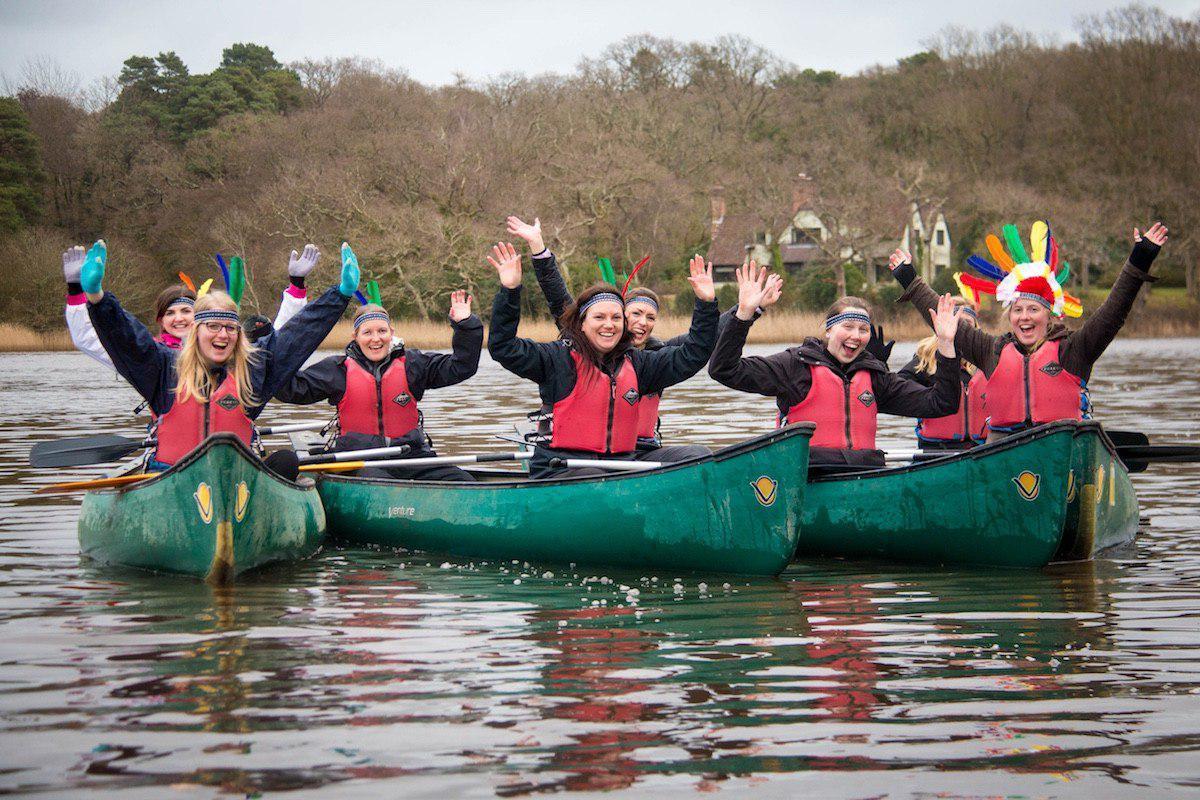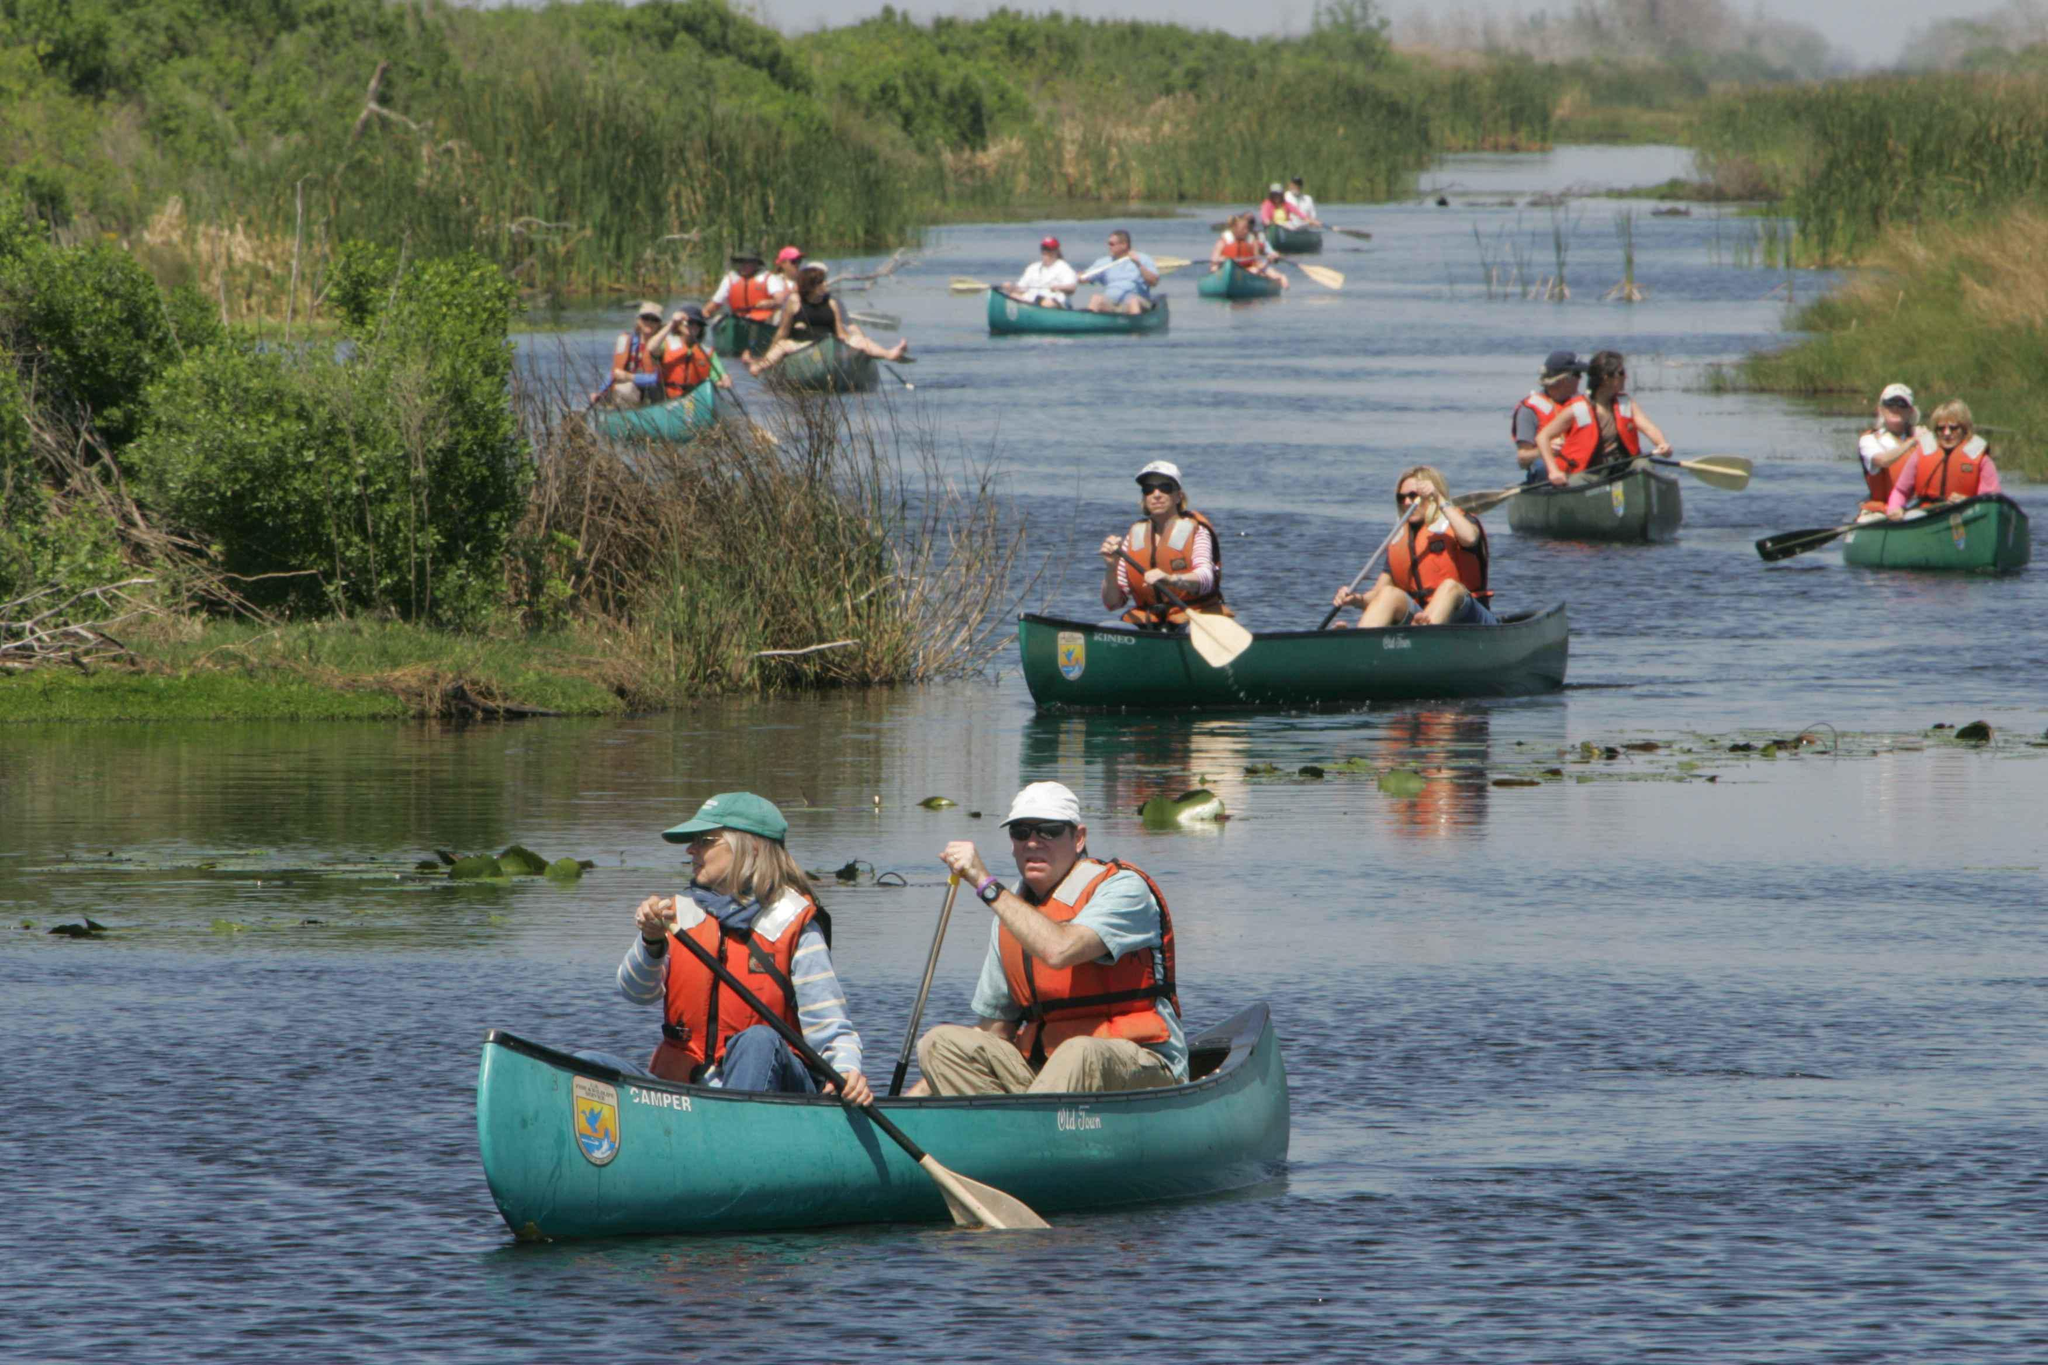The first image is the image on the left, the second image is the image on the right. For the images displayed, is the sentence "The left image includes a person standing by an empty canoe that is pulled up to the water's edge, with at least one other canoe on the water in the background." factually correct? Answer yes or no. No. The first image is the image on the left, the second image is the image on the right. Evaluate the accuracy of this statement regarding the images: "All the boats are in the water.". Is it true? Answer yes or no. Yes. 